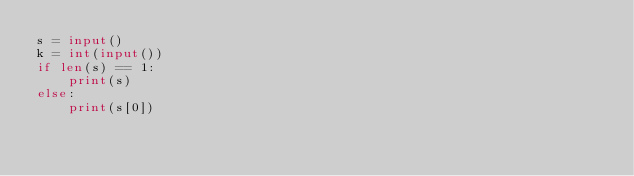<code> <loc_0><loc_0><loc_500><loc_500><_Python_>s = input()
k = int(input())
if len(s) == 1:
    print(s)
else:
    print(s[0])</code> 